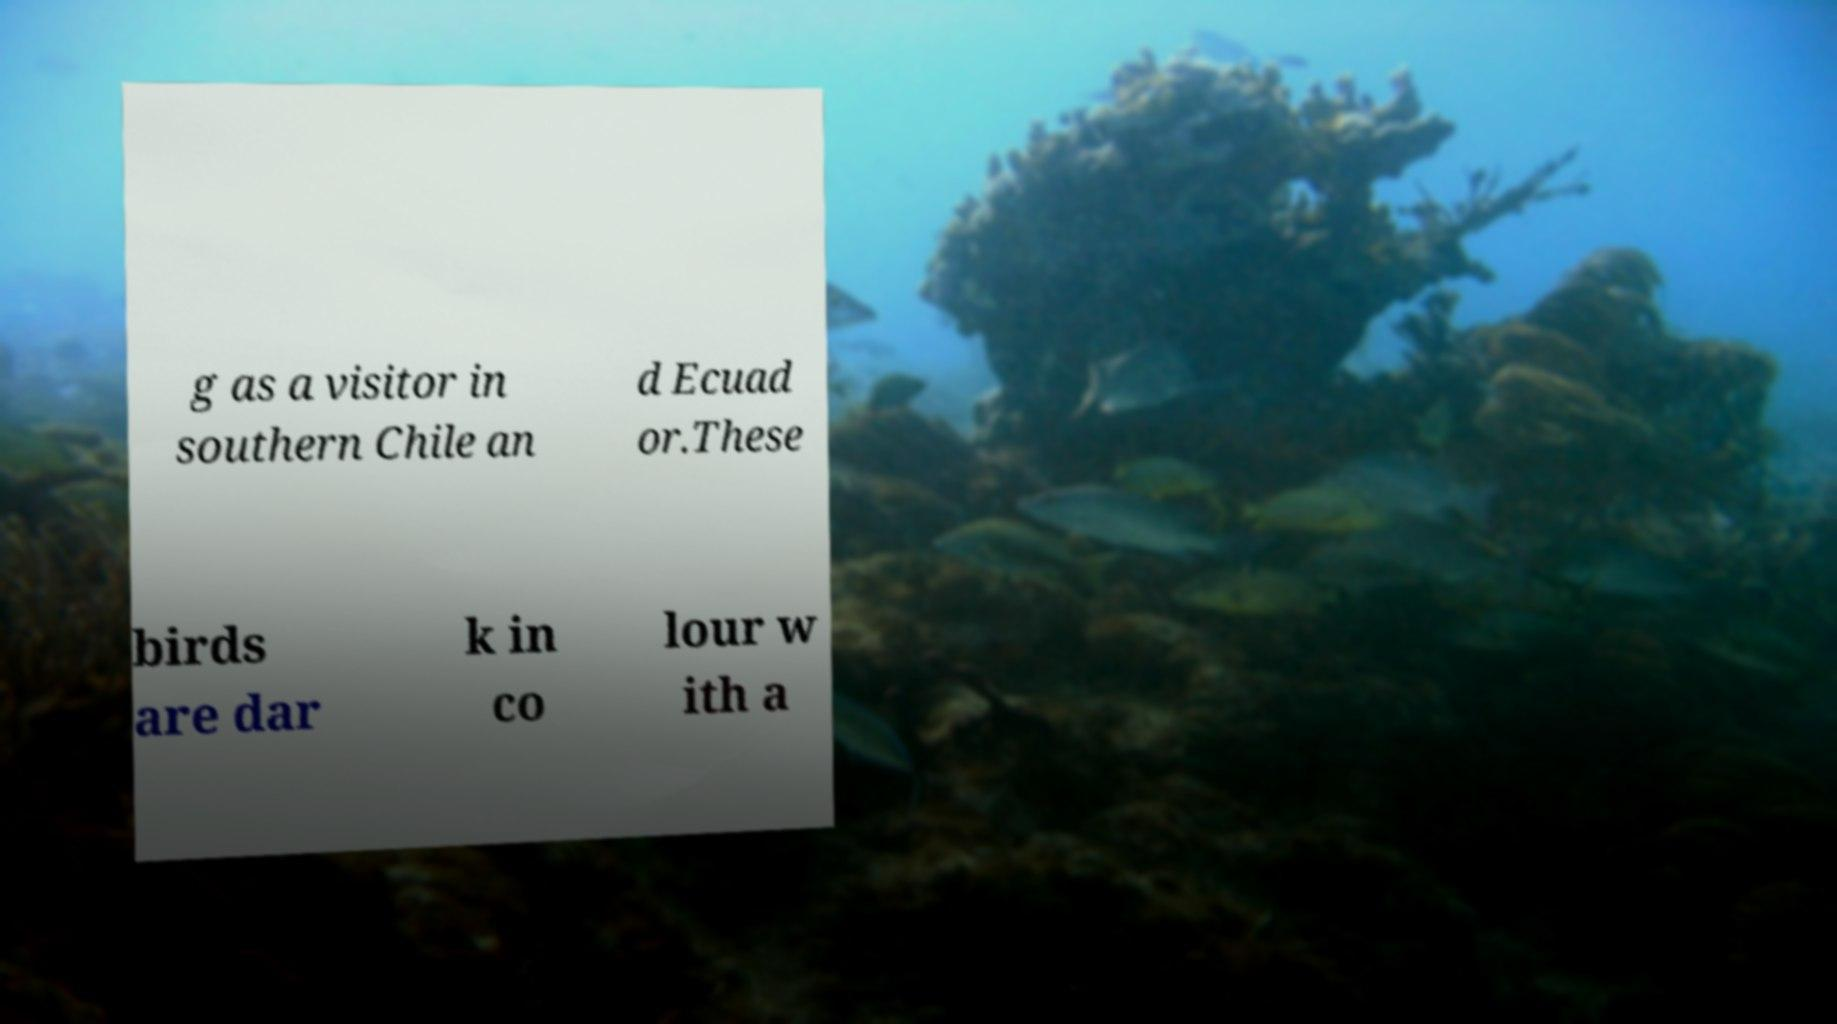I need the written content from this picture converted into text. Can you do that? g as a visitor in southern Chile an d Ecuad or.These birds are dar k in co lour w ith a 